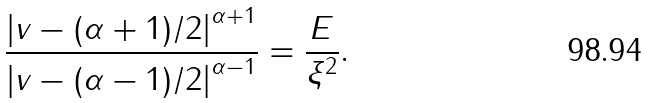Convert formula to latex. <formula><loc_0><loc_0><loc_500><loc_500>\frac { \left | v - ( \alpha + 1 ) / 2 \right | ^ { \alpha + 1 } } { \left | v - ( \alpha - 1 ) / 2 \right | ^ { \alpha - 1 } } = \frac { E } { \xi ^ { 2 } } .</formula> 